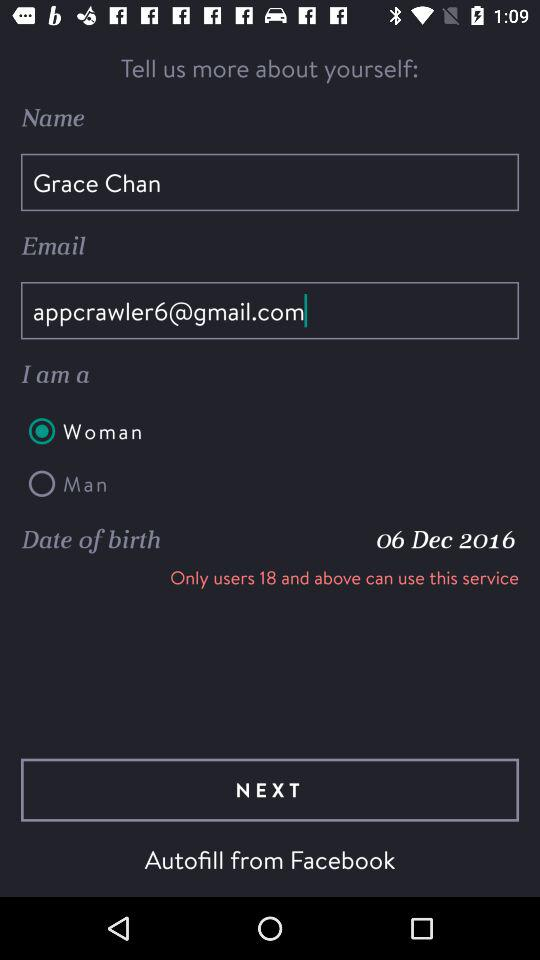Who is eligible to use this service? Users of age 18 and above can use this service. 